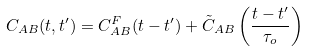Convert formula to latex. <formula><loc_0><loc_0><loc_500><loc_500>C _ { A B } ( t , t ^ { \prime } ) = C ^ { F } _ { A B } ( t - t ^ { \prime } ) + { \tilde { C } } _ { A B } \left ( \frac { t - t ^ { \prime } } { \tau _ { o } } \right )</formula> 